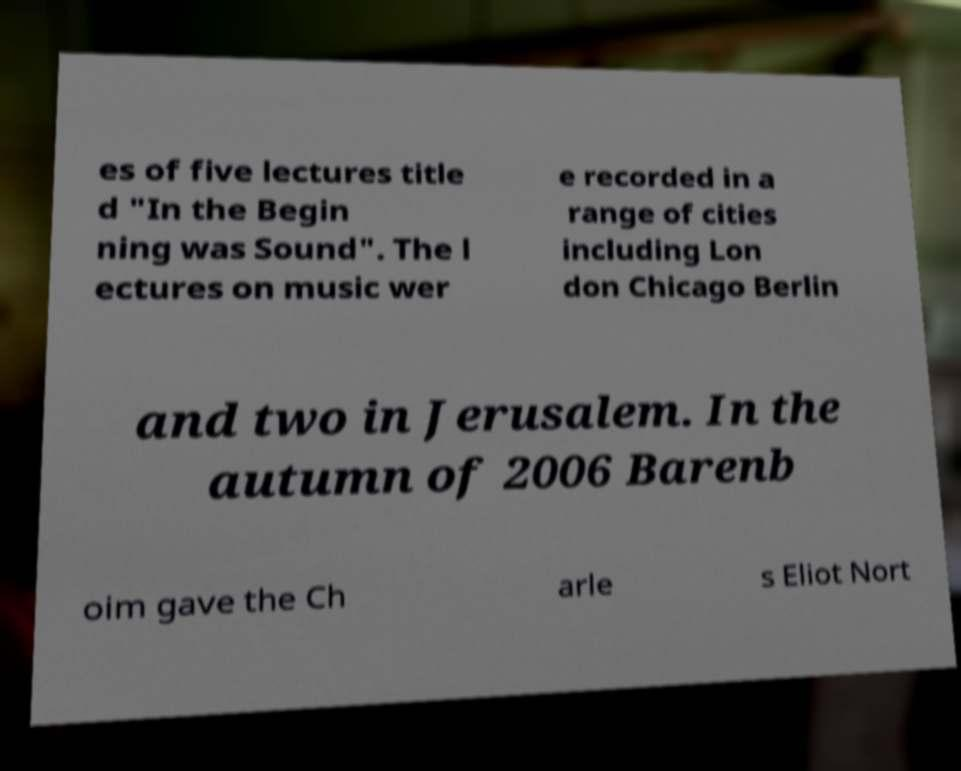Please read and relay the text visible in this image. What does it say? es of five lectures title d "In the Begin ning was Sound". The l ectures on music wer e recorded in a range of cities including Lon don Chicago Berlin and two in Jerusalem. In the autumn of 2006 Barenb oim gave the Ch arle s Eliot Nort 